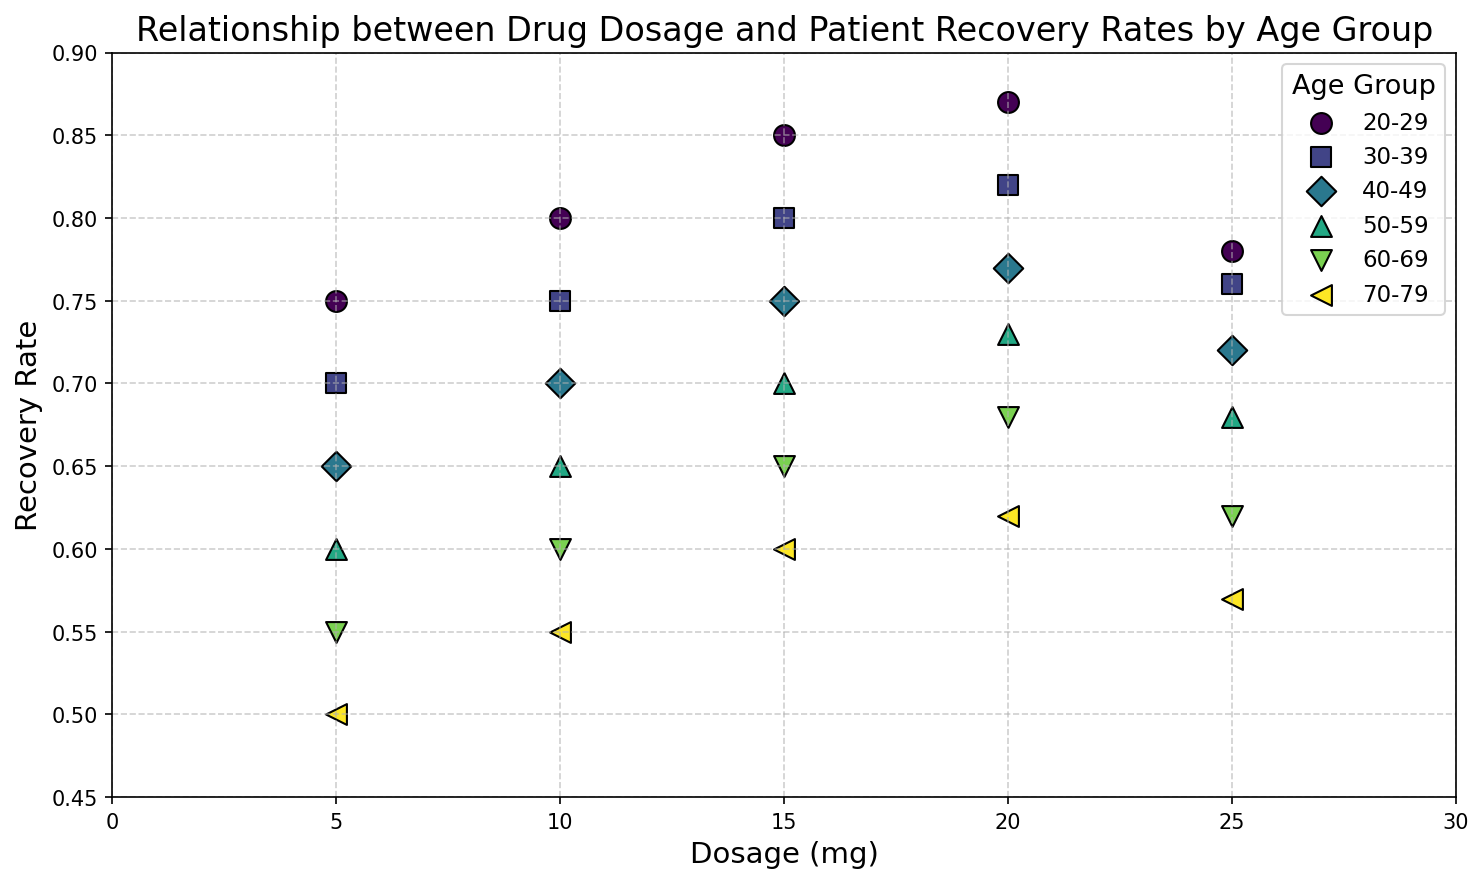What's the overall trend in recovery rate with increasing dosage across all age groups? The recovery rate generally increases as the dosage increases for all age groups, but the exact rate of increase varies for different age groups. For example, younger age groups show a steeper increase whereas older age groups show a more gradual increase.
Answer: Recovery rate generally increases Which age group shows the highest recovery rate at the lowest dosage? At a dosage of 5 mg, the age group 20-29 shows the highest recovery rate of 0.75.
Answer: 20-29 How does the maximum recovery rate compare between the age group 20-29 and 70-79? The maximum recovery rate for age group 20-29 is 0.87 at a dosage of 20 mg, whereas for age group 70-79, it is 0.62 at a dosage of 20 mg. Therefore, the maximum recovery rate for age group 20-29 is higher.
Answer: Age group 20-29 has a higher maximum recovery rate At which dosage do all age groups exhibit the lowest recovery rate, and what are those rates? Across all age groups, the lowest recovery rates are observed at a dosage of 5 mg. The recovery rates are 0.75 (20-29), 0.70 (30-39), 0.65 (40-49), 0.60 (50-59), 0.55 (60-69), and 0.50 (70-79).
Answer: Dosage 5 mg, rates: 0.75, 0.70, 0.65, 0.60, 0.55, 0.50 What visual clue helps you identify different age groups in the scatter plot? Different age groups are identified by specific markers (e.g., circles, squares) and different colors for each group.
Answer: Markers and colors Which age group shows the least variability in recovery rate as the dosage increases from 5 to 25 mg? The age group 70-79 shows the least variability with recovery rates ranging from 0.50 to 0.62 as the dosage increases from 5 to 25 mg.
Answer: 70-79 For the age group 30-39, is there a clear peak in the recovery rate, and if so, at which dosage? The peak recovery rate for age group 30-39 is at 20 mg, with a recovery rate of 0.82.
Answer: Yes, at 20 mg Do any age groups exhibit a decline in recovery rate after a certain dosage? If so, which ones and at what dosage? Yes, age groups 20-29, 30-39, 40-49, 50-59, 60-69, and 70-79 exhibit a slight decline in recovery rate after 20 mg. For example, age group 20-29 has a recovery rate drop from 0.87 at 20 mg to 0.78 at 25 mg.
Answer: All age groups after 20 mg What is the general shape of the relationship between recovery rate and dosage for most age groups? The relationship for most age groups shows an initial increase in recovery rate with increasing dosage, peaking around 15-20 mg, and then slightly declining or leveling off.
Answer: Increasing, peaking, then declining Compare the recovery rate trends between the youngest and oldest age groups. The youngest age group (20-29) shows a sharp increase in recovery rate with increasing dosage, peaking at 20 mg. The oldest age group (70-79) shows a less steep increase and a lower peak at the same dosage.
Answer: Younger group: sharp increase; older group: gradual increase 